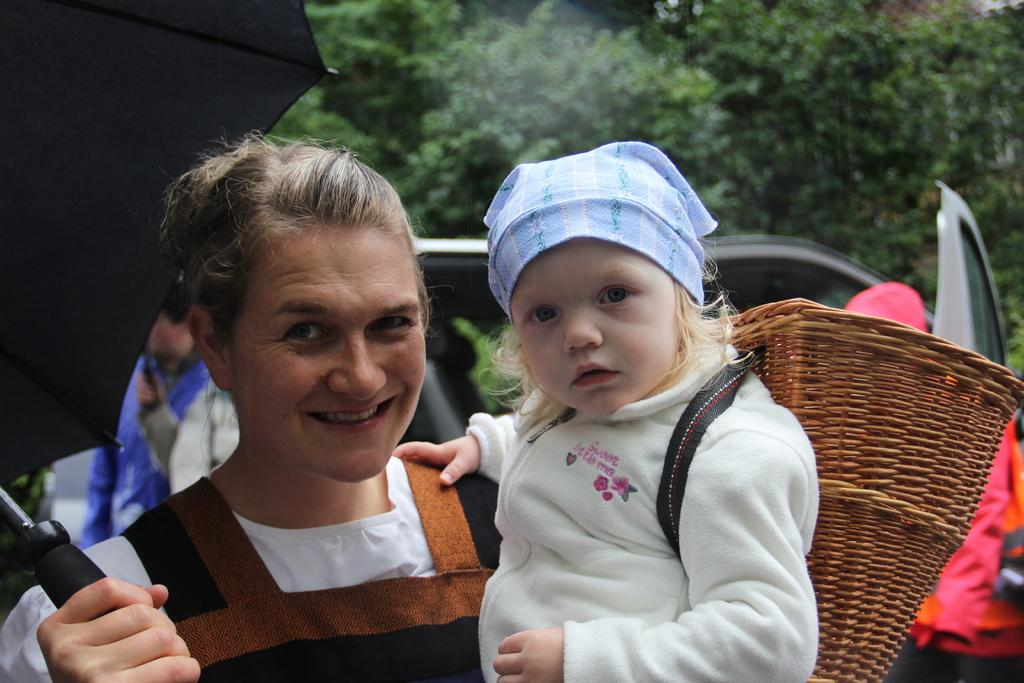Who is the main subject in the foreground of the image? There is a woman in the foreground of the image. What is the woman holding in the image? The woman is holding a baby and an umbrella. What can be seen in the background of the image? There is a car and trees in the background of the image. What is the weather like in the image? The image was taken during a rainy day. Where was the image taken? The image was taken on a road. What type of chair is visible in the image? There is no chair present in the image. What cable is being used by the woman to communicate with others in the image? There is no cable or communication device visible in the image. 